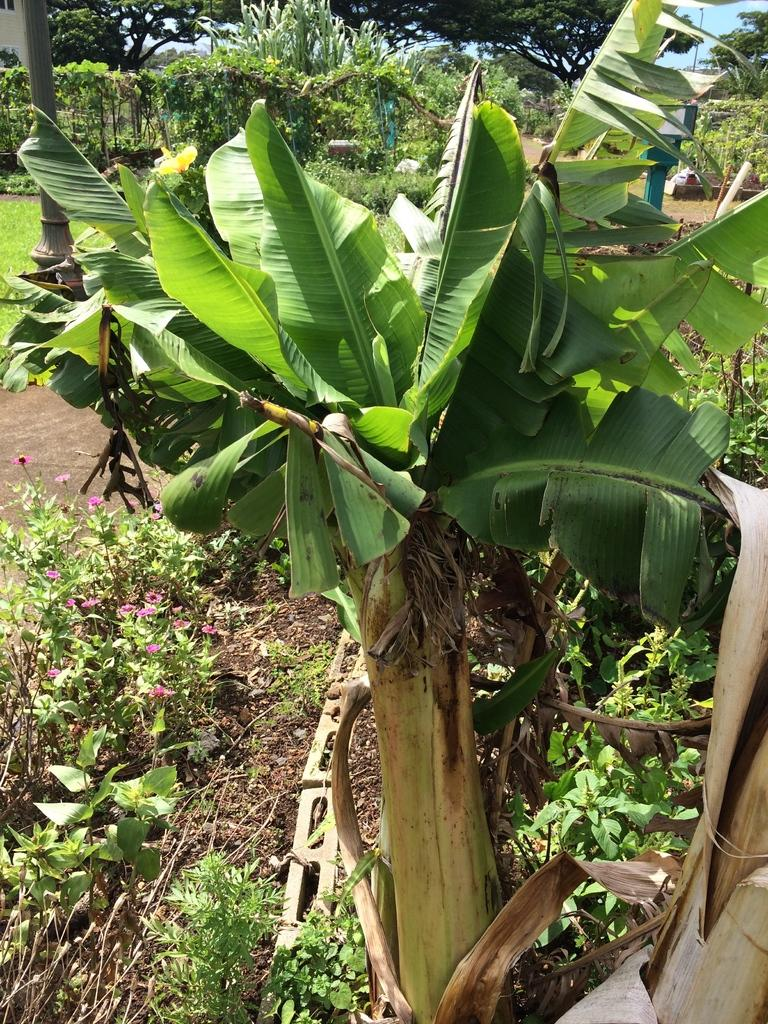What is located in the foreground of the image? There is a tree in the foreground of the image. What can be seen in the background of the image? In the background of the image, there are plants, flowers, trees, a path, a pole, and grass. Can you describe the vegetation in the image? The image features a tree in the foreground and various plants, flowers, and trees in the background. What type of ground cover is present in the image? Grass is present in the background of the image. What man-made object is visible in the background of the image? There is a pole in the background of the image. Where is the cave located in the image? There is no cave present in the image. What type of furniture is visible in the image? There is no furniture, such as a sofa, present in the image. 